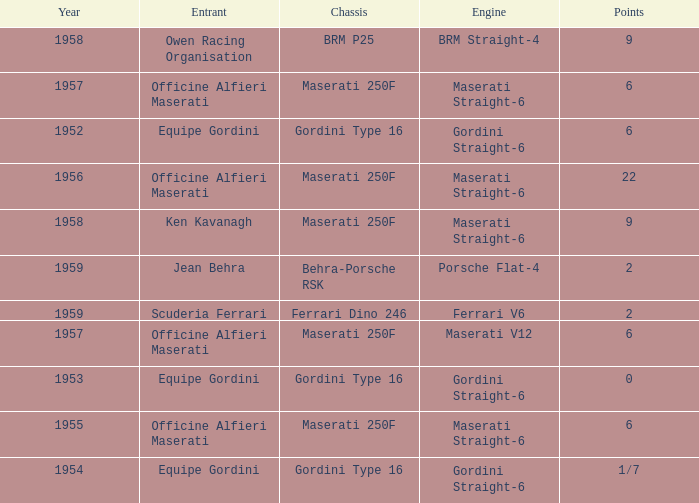What is the entrant of a chassis maserati 250f, also has 6 points and older than year 1957? Officine Alfieri Maserati. 